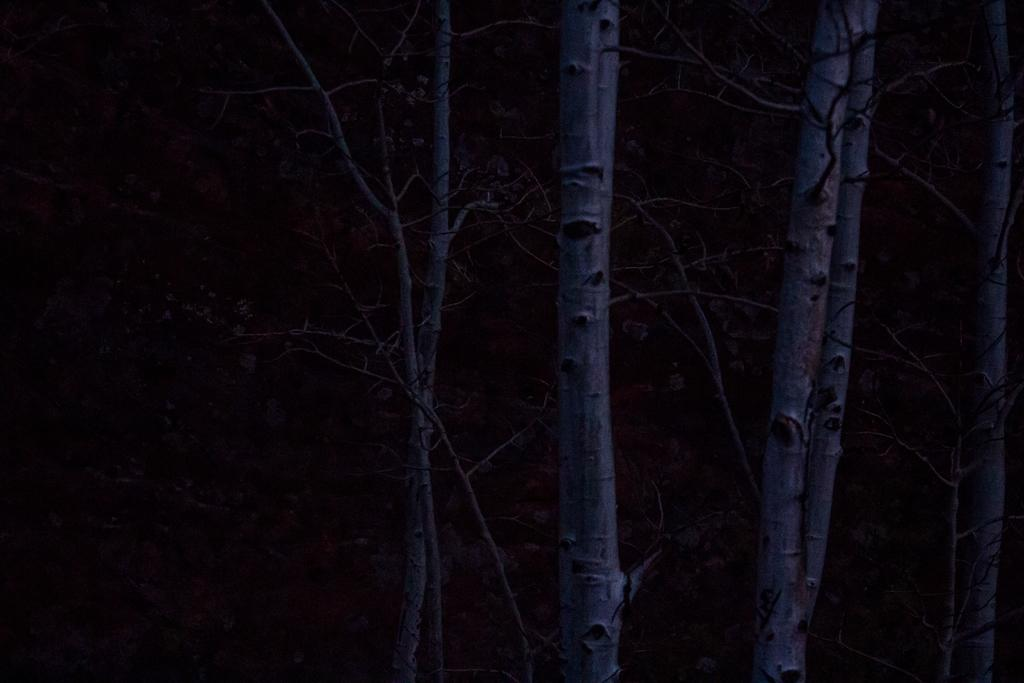What type of vegetation can be seen in the image? There are trees in the image. How would you describe the overall lighting in the image? The background of the image is dark. What type of cork can be seen in the image? There is no cork present in the image. What type of pleasure can be derived from looking at the trees in the image? The image does not convey any specific pleasure or emotion, as it only shows trees and a dark background. 